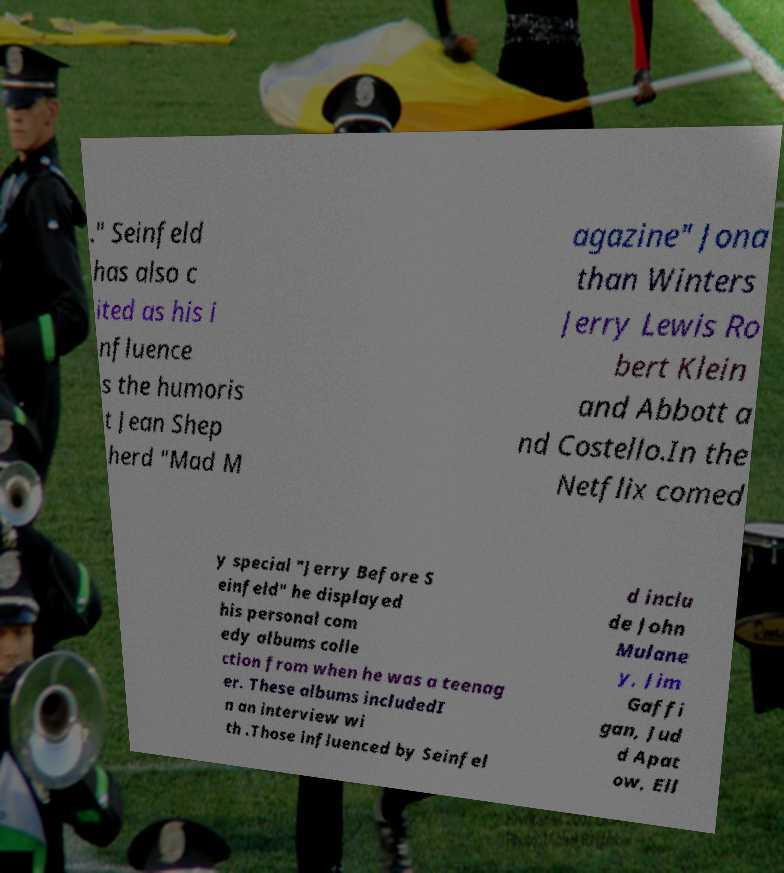Please identify and transcribe the text found in this image. ." Seinfeld has also c ited as his i nfluence s the humoris t Jean Shep herd "Mad M agazine" Jona than Winters Jerry Lewis Ro bert Klein and Abbott a nd Costello.In the Netflix comed y special "Jerry Before S einfeld" he displayed his personal com edy albums colle ction from when he was a teenag er. These albums includedI n an interview wi th .Those influenced by Seinfel d inclu de John Mulane y, Jim Gaffi gan, Jud d Apat ow, Ell 